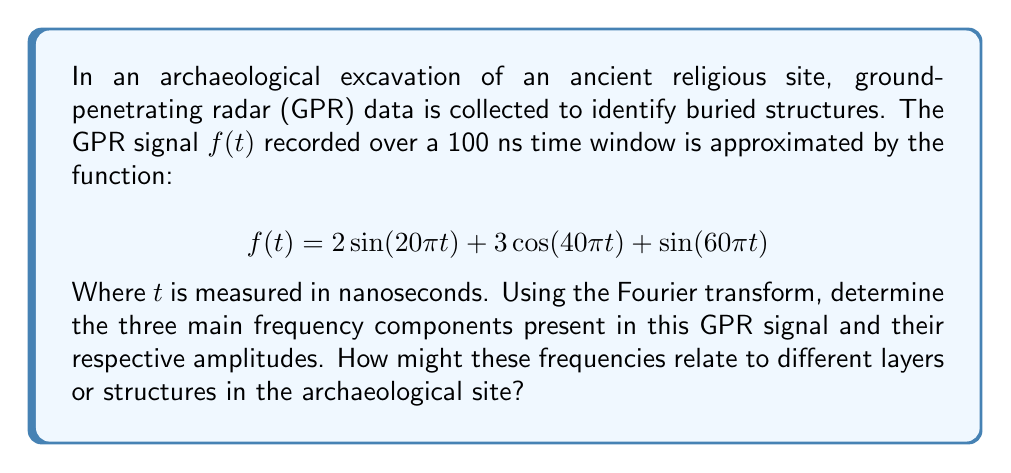Solve this math problem. To solve this problem, we'll follow these steps:

1) Recall the Fourier transform pairs for sine and cosine functions:
   
   $$\mathcal{F}\{\sin(2\pi f_0 t)\} = \frac{i}{2}[\delta(f+f_0) - \delta(f-f_0)]$$
   $$\mathcal{F}\{\cos(2\pi f_0 t)\} = \frac{1}{2}[\delta(f+f_0) + \delta(f-f_0)]$$

2) Identify the frequency components in the given function:
   
   $2\sin(20\pi t)$: $f_1 = 10$ Hz
   $3\cos(40\pi t)$: $f_2 = 20$ Hz
   $\sin(60\pi t)$: $f_3 = 30$ Hz

3) Apply the Fourier transform to each term:
   
   $$\mathcal{F}\{2\sin(20\pi t)\} = i[\delta(f+10) - \delta(f-10)]$$
   $$\mathcal{F}\{3\cos(40\pi t)\} = \frac{3}{2}[\delta(f+20) + \delta(f-20)]$$
   $$\mathcal{F}\{\sin(60\pi t)\} = \frac{i}{2}[\delta(f+30) - \delta(f-30)]$$

4) The amplitude of each frequency component is determined by the coefficient:
   
   $f_1 = 10$ Hz: Amplitude = 2
   $f_2 = 20$ Hz: Amplitude = 3
   $f_3 = 30$ Hz: Amplitude = 1

5) Interpretation in the context of archaeology:
   These frequencies could correspond to different layers or structures in the site. Lower frequencies (10 Hz) might represent deeper, larger structures, while higher frequencies (30 Hz) could indicate shallower or smaller features. The 20 Hz component, having the largest amplitude, might represent a significant layer or structure of particular interest to the archaeological study.
Answer: The three main frequency components and their amplitudes are:
1) 10 Hz with amplitude 2
2) 20 Hz with amplitude 3
3) 30 Hz with amplitude 1

These frequencies could correspond to different archaeological features, with lower frequencies potentially representing deeper or larger structures, and higher frequencies indicating shallower or smaller features. The 20 Hz component, having the largest amplitude, might be of particular archaeological significance. 